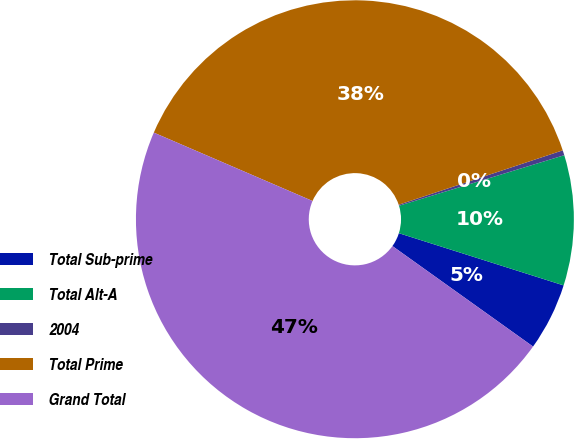<chart> <loc_0><loc_0><loc_500><loc_500><pie_chart><fcel>Total Sub-prime<fcel>Total Alt-A<fcel>2004<fcel>Total Prime<fcel>Grand Total<nl><fcel>4.99%<fcel>9.61%<fcel>0.37%<fcel>38.43%<fcel>46.6%<nl></chart> 